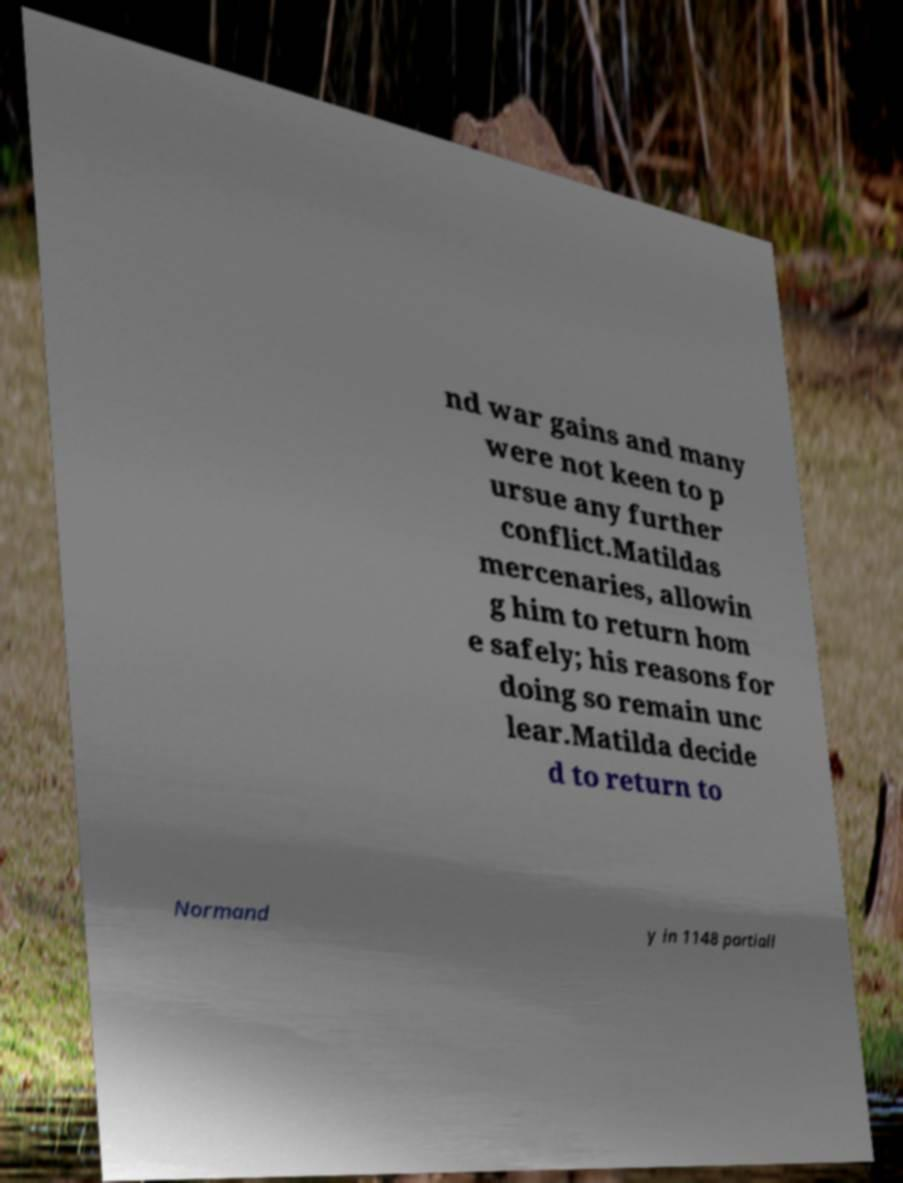What messages or text are displayed in this image? I need them in a readable, typed format. nd war gains and many were not keen to p ursue any further conflict.Matildas mercenaries, allowin g him to return hom e safely; his reasons for doing so remain unc lear.Matilda decide d to return to Normand y in 1148 partiall 